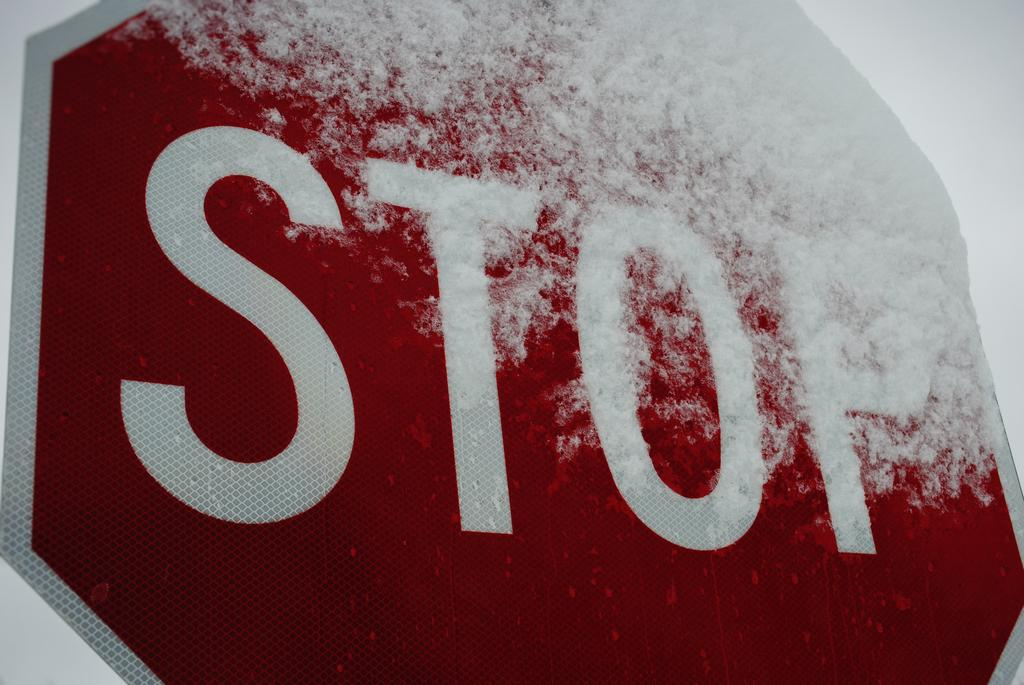Provide a one-sentence caption for the provided image. A closeup of a stop sign covered in snow on top. 